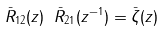Convert formula to latex. <formula><loc_0><loc_0><loc_500><loc_500>\bar { R } _ { 1 2 } ( z ) \ \bar { R } _ { 2 1 } ( z ^ { - 1 } ) = \bar { \zeta } ( z )</formula> 